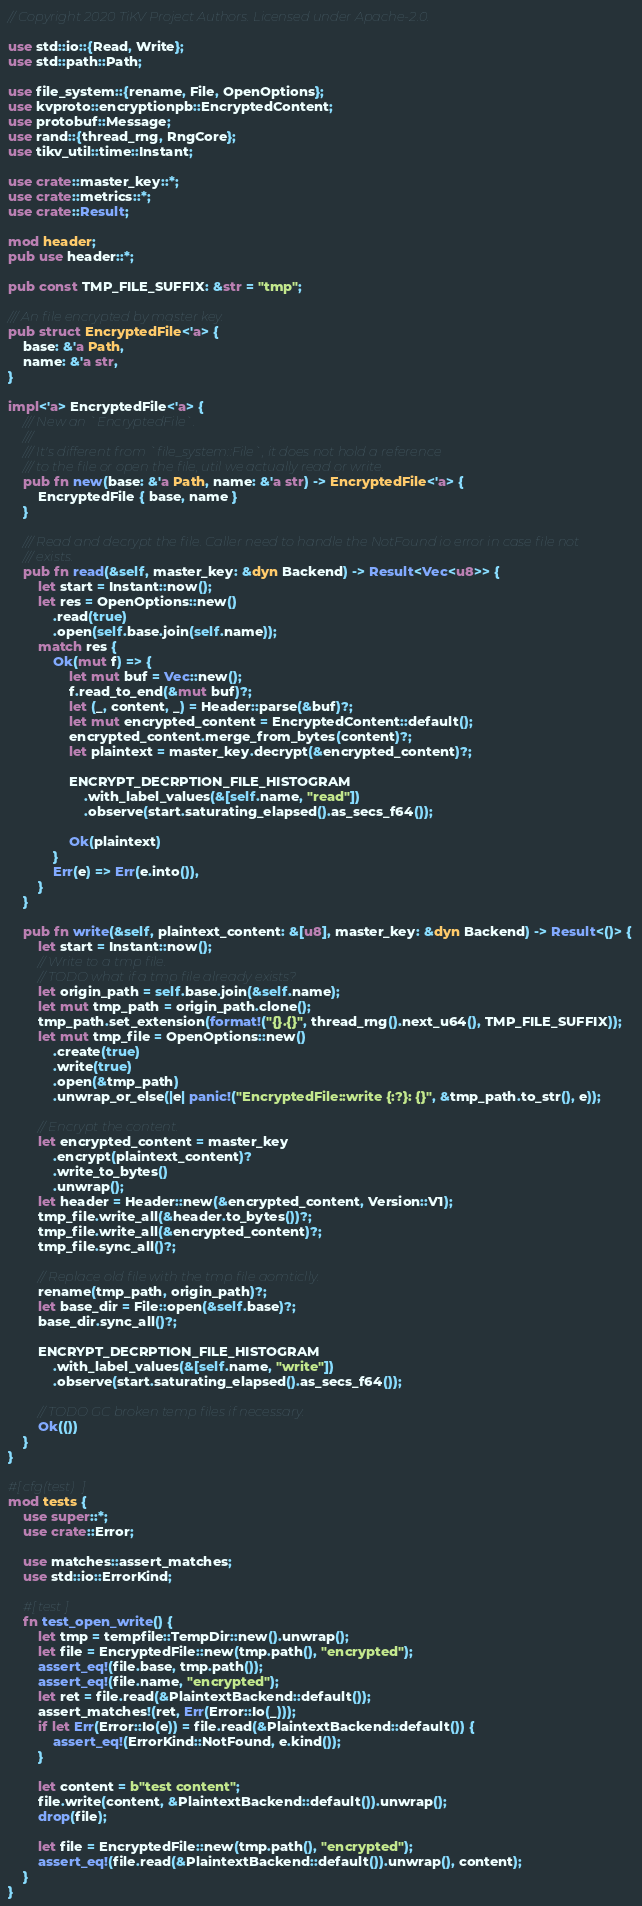<code> <loc_0><loc_0><loc_500><loc_500><_Rust_>// Copyright 2020 TiKV Project Authors. Licensed under Apache-2.0.

use std::io::{Read, Write};
use std::path::Path;

use file_system::{rename, File, OpenOptions};
use kvproto::encryptionpb::EncryptedContent;
use protobuf::Message;
use rand::{thread_rng, RngCore};
use tikv_util::time::Instant;

use crate::master_key::*;
use crate::metrics::*;
use crate::Result;

mod header;
pub use header::*;

pub const TMP_FILE_SUFFIX: &str = "tmp";

/// An file encrypted by master key.
pub struct EncryptedFile<'a> {
    base: &'a Path,
    name: &'a str,
}

impl<'a> EncryptedFile<'a> {
    /// New an `EncryptedFile`.
    ///
    /// It's different from `file_system::File`, it does not hold a reference
    /// to the file or open the file, util we actually read or write.
    pub fn new(base: &'a Path, name: &'a str) -> EncryptedFile<'a> {
        EncryptedFile { base, name }
    }

    /// Read and decrypt the file. Caller need to handle the NotFound io error in case file not
    /// exists.
    pub fn read(&self, master_key: &dyn Backend) -> Result<Vec<u8>> {
        let start = Instant::now();
        let res = OpenOptions::new()
            .read(true)
            .open(self.base.join(self.name));
        match res {
            Ok(mut f) => {
                let mut buf = Vec::new();
                f.read_to_end(&mut buf)?;
                let (_, content, _) = Header::parse(&buf)?;
                let mut encrypted_content = EncryptedContent::default();
                encrypted_content.merge_from_bytes(content)?;
                let plaintext = master_key.decrypt(&encrypted_content)?;

                ENCRYPT_DECRPTION_FILE_HISTOGRAM
                    .with_label_values(&[self.name, "read"])
                    .observe(start.saturating_elapsed().as_secs_f64());

                Ok(plaintext)
            }
            Err(e) => Err(e.into()),
        }
    }

    pub fn write(&self, plaintext_content: &[u8], master_key: &dyn Backend) -> Result<()> {
        let start = Instant::now();
        // Write to a tmp file.
        // TODO what if a tmp file already exists?
        let origin_path = self.base.join(&self.name);
        let mut tmp_path = origin_path.clone();
        tmp_path.set_extension(format!("{}.{}", thread_rng().next_u64(), TMP_FILE_SUFFIX));
        let mut tmp_file = OpenOptions::new()
            .create(true)
            .write(true)
            .open(&tmp_path)
            .unwrap_or_else(|e| panic!("EncryptedFile::write {:?}: {}", &tmp_path.to_str(), e));

        // Encrypt the content.
        let encrypted_content = master_key
            .encrypt(plaintext_content)?
            .write_to_bytes()
            .unwrap();
        let header = Header::new(&encrypted_content, Version::V1);
        tmp_file.write_all(&header.to_bytes())?;
        tmp_file.write_all(&encrypted_content)?;
        tmp_file.sync_all()?;

        // Replace old file with the tmp file aomticlly.
        rename(tmp_path, origin_path)?;
        let base_dir = File::open(&self.base)?;
        base_dir.sync_all()?;

        ENCRYPT_DECRPTION_FILE_HISTOGRAM
            .with_label_values(&[self.name, "write"])
            .observe(start.saturating_elapsed().as_secs_f64());

        // TODO GC broken temp files if necessary.
        Ok(())
    }
}

#[cfg(test)]
mod tests {
    use super::*;
    use crate::Error;

    use matches::assert_matches;
    use std::io::ErrorKind;

    #[test]
    fn test_open_write() {
        let tmp = tempfile::TempDir::new().unwrap();
        let file = EncryptedFile::new(tmp.path(), "encrypted");
        assert_eq!(file.base, tmp.path());
        assert_eq!(file.name, "encrypted");
        let ret = file.read(&PlaintextBackend::default());
        assert_matches!(ret, Err(Error::Io(_)));
        if let Err(Error::Io(e)) = file.read(&PlaintextBackend::default()) {
            assert_eq!(ErrorKind::NotFound, e.kind());
        }

        let content = b"test content";
        file.write(content, &PlaintextBackend::default()).unwrap();
        drop(file);

        let file = EncryptedFile::new(tmp.path(), "encrypted");
        assert_eq!(file.read(&PlaintextBackend::default()).unwrap(), content);
    }
}
</code> 